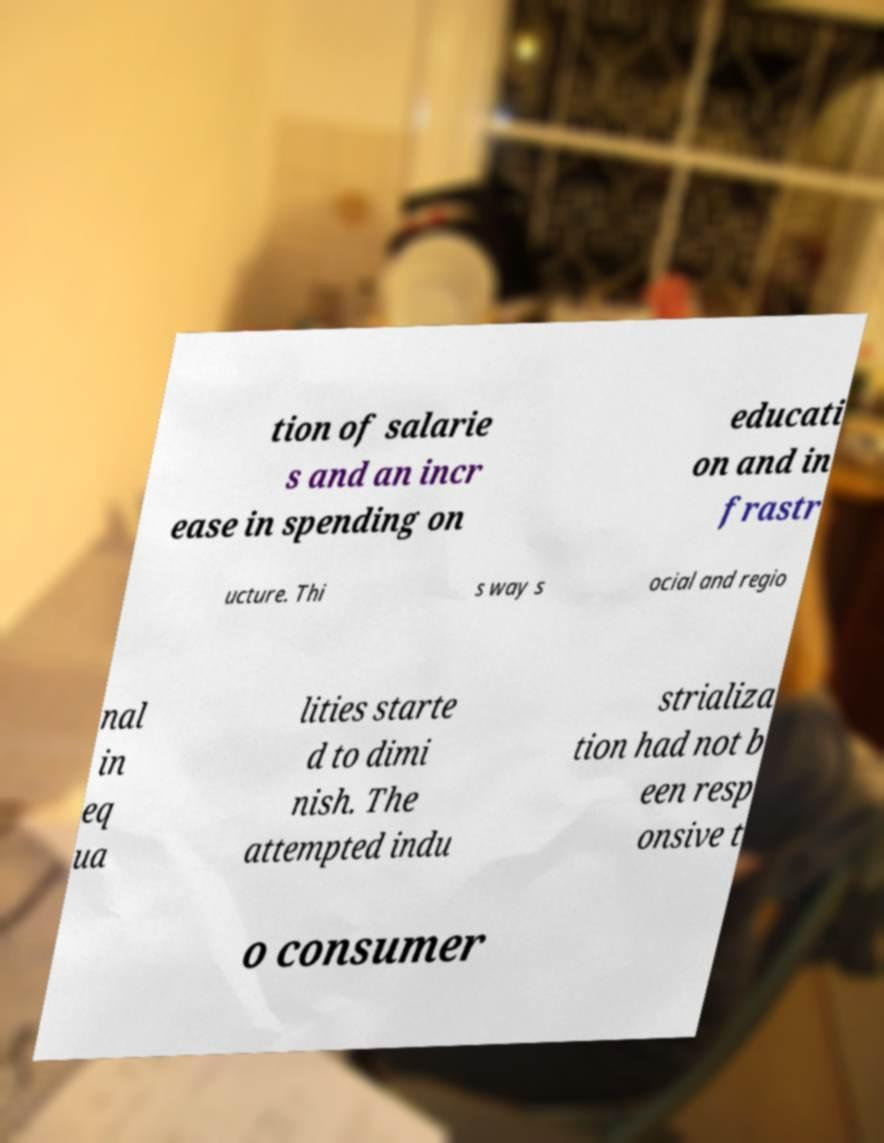Could you extract and type out the text from this image? tion of salarie s and an incr ease in spending on educati on and in frastr ucture. Thi s way s ocial and regio nal in eq ua lities starte d to dimi nish. The attempted indu strializa tion had not b een resp onsive t o consumer 